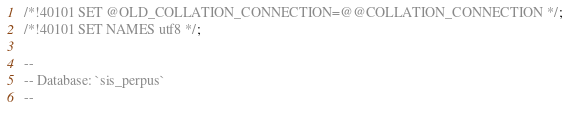Convert code to text. <code><loc_0><loc_0><loc_500><loc_500><_SQL_>/*!40101 SET @OLD_COLLATION_CONNECTION=@@COLLATION_CONNECTION */;
/*!40101 SET NAMES utf8 */;

--
-- Database: `sis_perpus`
--
</code> 